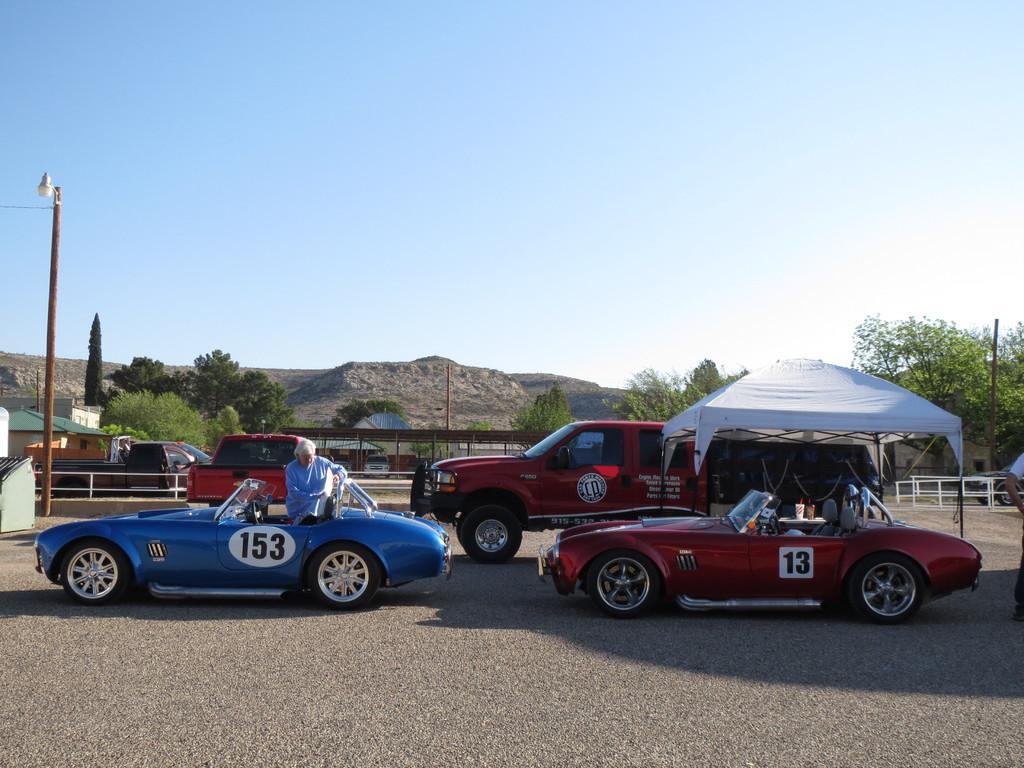How would you summarize this image in a sentence or two? In this image there is a road, on the road, on the road few vehicles and tents , there is a person visible in the blue color vehicle, in the background there is the hill, pole ,trees ,fence and house visible ,at the top there is the sky. 